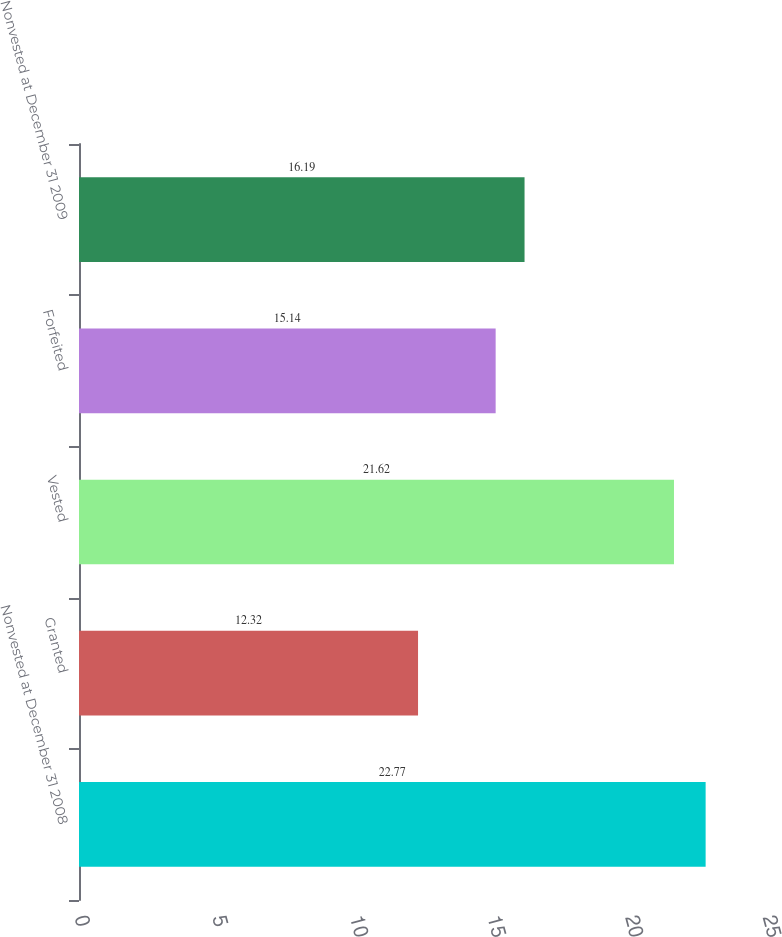Convert chart to OTSL. <chart><loc_0><loc_0><loc_500><loc_500><bar_chart><fcel>Nonvested at December 31 2008<fcel>Granted<fcel>Vested<fcel>Forfeited<fcel>Nonvested at December 31 2009<nl><fcel>22.77<fcel>12.32<fcel>21.62<fcel>15.14<fcel>16.19<nl></chart> 